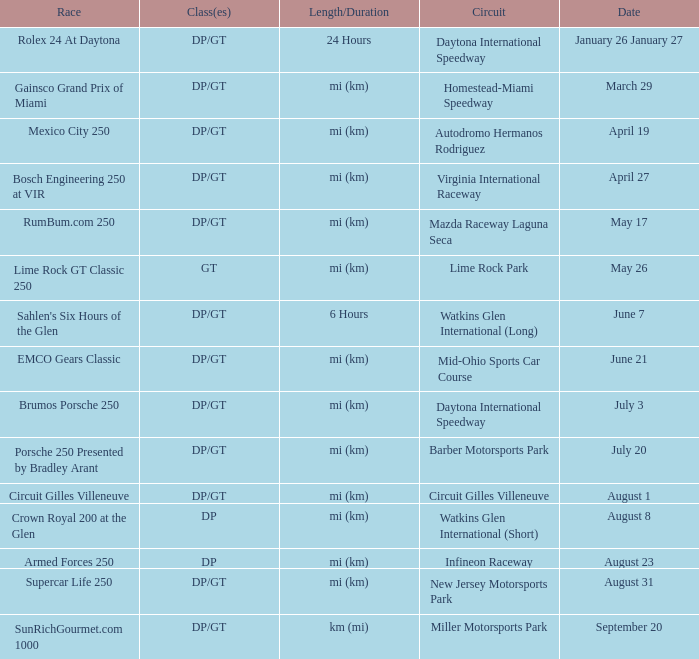What was the circuit that held a race on september 20? Miller Motorsports Park. 